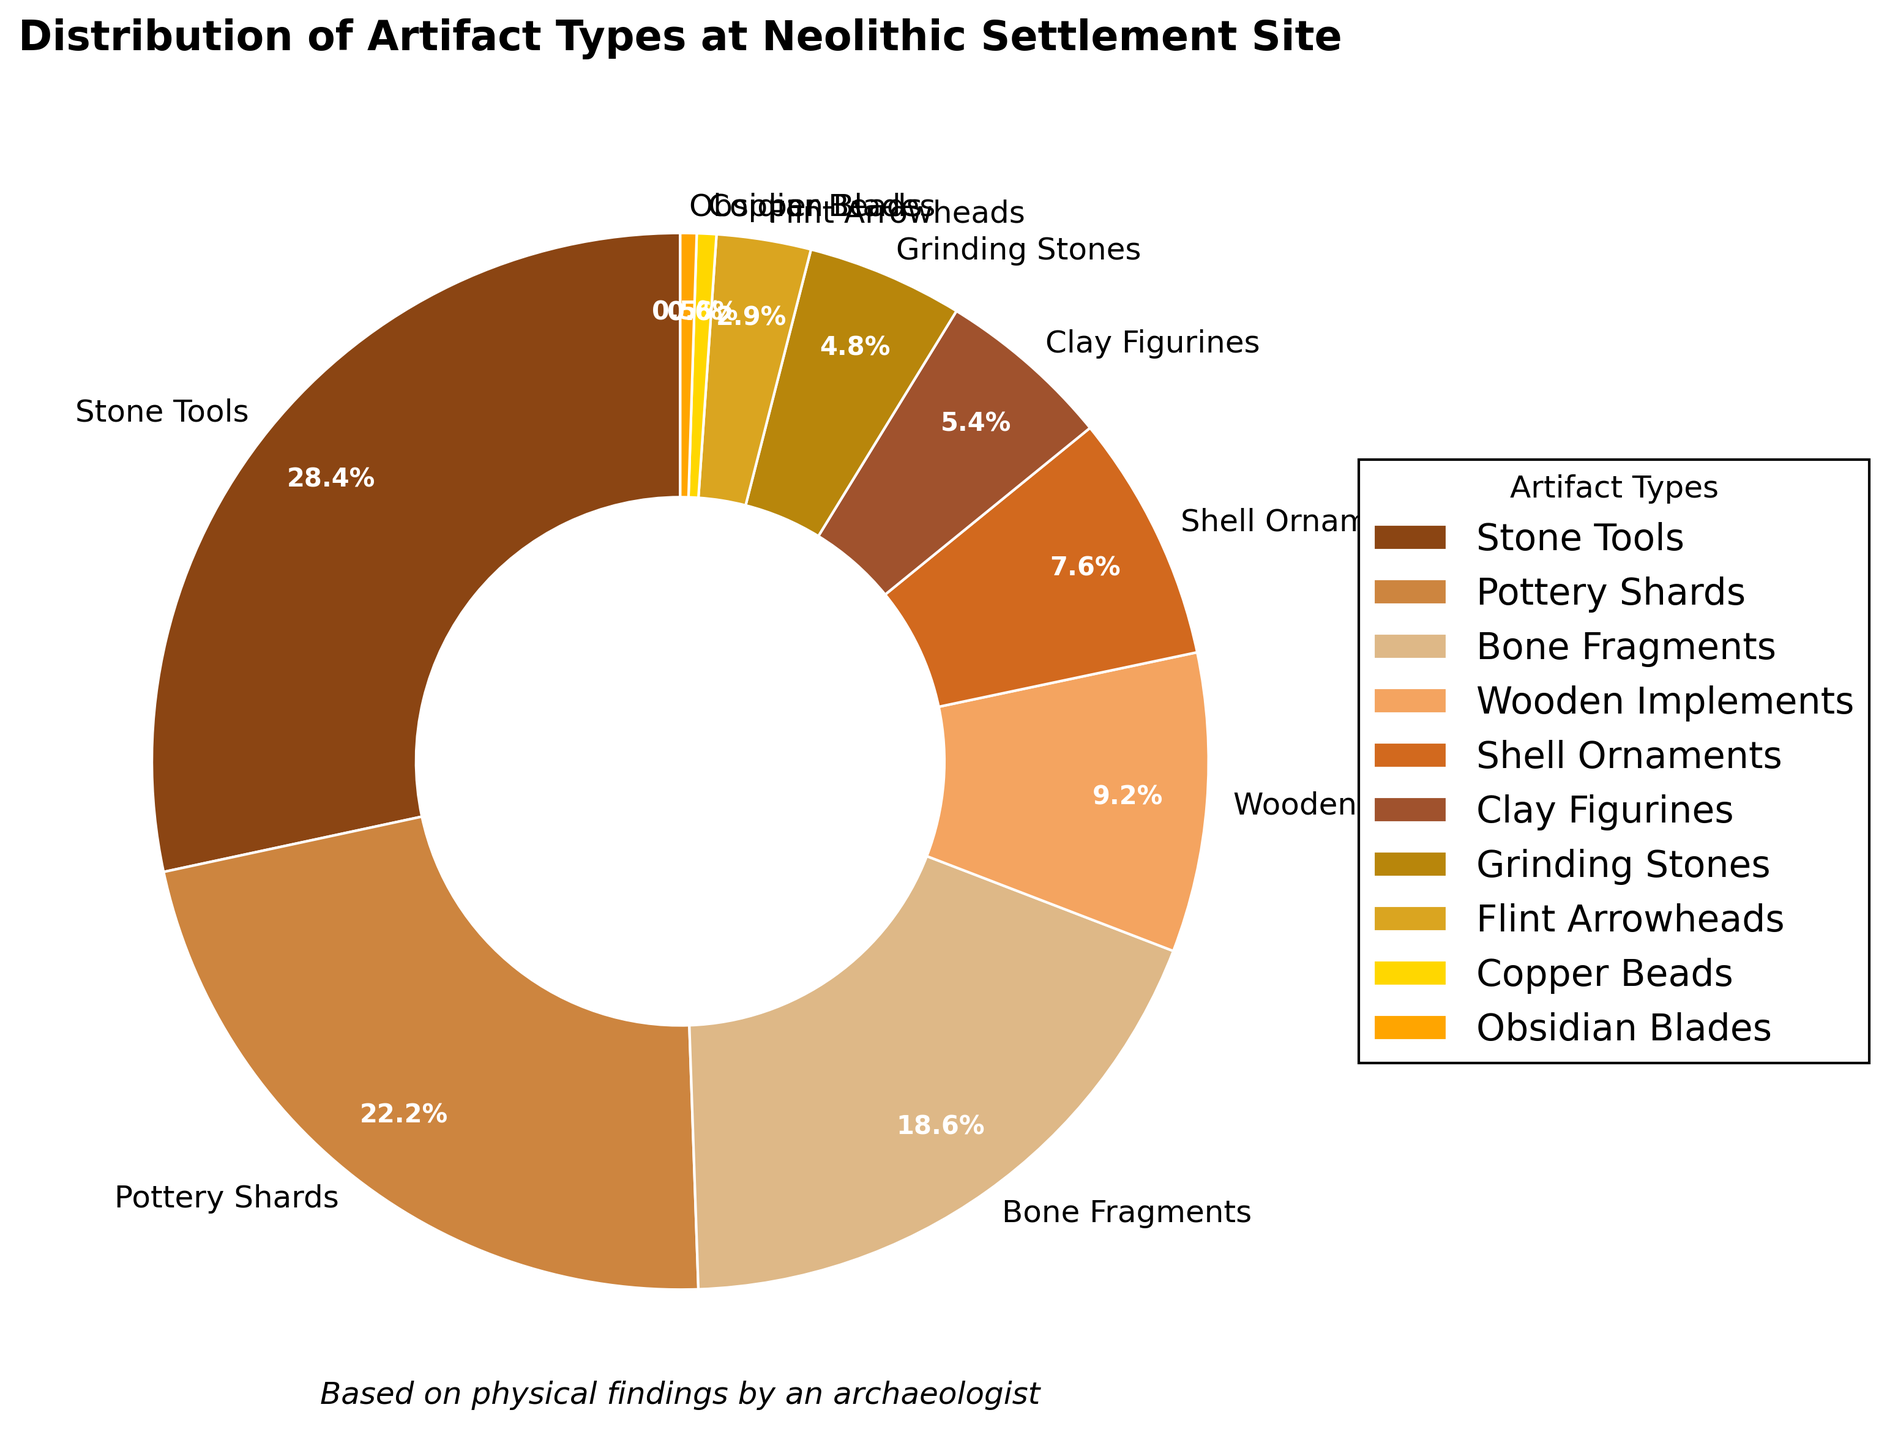What's the most common type of artifact found at the Neolithic settlement site? The pie chart shows the distribution of different artifact types by percentage. The segment with the largest percentage represents the most common type. Here, the "Stone Tools" segment is the largest at 28.5%.
Answer: Stone Tools What percentage of the artifacts found are pottery shards? The pie chart includes labeled segments indicating the percentage of each artifact type. The segment labeled "Pottery Shards" shows 22.3%.
Answer: 22.3% What is the combined percentage of Bone Fragments and Wooden Implements? The chart shows the percentages for "Bone Fragments" and "Wooden Implements" as 18.7% and 9.2%, respectively. Adding these gives 18.7% + 9.2% = 27.9%.
Answer: 27.9% How does the percentage of Clay Figurines compare to that of Shell Ornaments? The pie chart shows that Clay Figurines make up 5.4% of the artifacts, while Shell Ornaments constitute 7.6%. Clay Figurines have a lower percentage than Shell Ornaments.
Answer: Clay Figurines have a lower percentage Identify the artifact type with the smallest representation and its percentage. The smallest segment in the pie chart represents "Obsidian Blades" with a percentage of 0.5%.
Answer: Obsidian Blades, 0.5% Which artifact types make up less than 5% of the findings? The data shows the percentages for each type. Those with less than 5% are "Grinding Stones" (4.8%), "Flint Arrowheads" (2.9%), "Copper Beads" (0.6%), and "Obsidian Blades" (0.5%).
Answer: Grinding Stones, Flint Arrowheads, Copper Beads, Obsidian Blades What is the total percentage of artifacts that are either Stone Tools or Pottery Shards? Adding the percentages for "Stone Tools" (28.5%) and "Pottery Shards" (22.3%) gives 50.8%.
Answer: 50.8% Which artifact type forms the smallest segment after combining Copper Beads and Obsidian Blades? Copper Beads have 0.6% and Obsidian Blades 0.5%, summing to 1.1%. This is still smaller than other types.
Answer: Combined Copper Beads and Obsidian Blades What is the visual attribute used to differentiate each artifact type in the pie chart? The pie chart uses different colors to represent each artifact type, with distinctively different shades and hues for each segment.
Answer: Different colors 